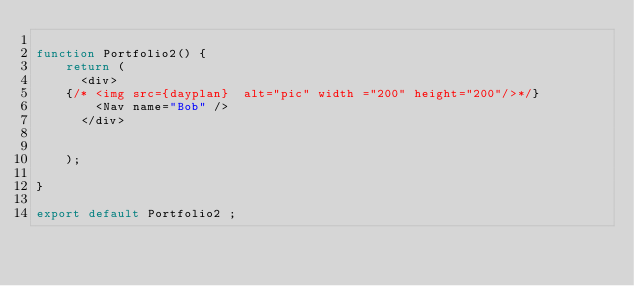Convert code to text. <code><loc_0><loc_0><loc_500><loc_500><_JavaScript_>
function Portfolio2() {
    return (
      <div>
    {/* <img src={dayplan}  alt="pic" width ="200" height="200"/>*/}  
        <Nav name="Bob" />
      </div>
      

    );

}   

export default Portfolio2 ;
</code> 